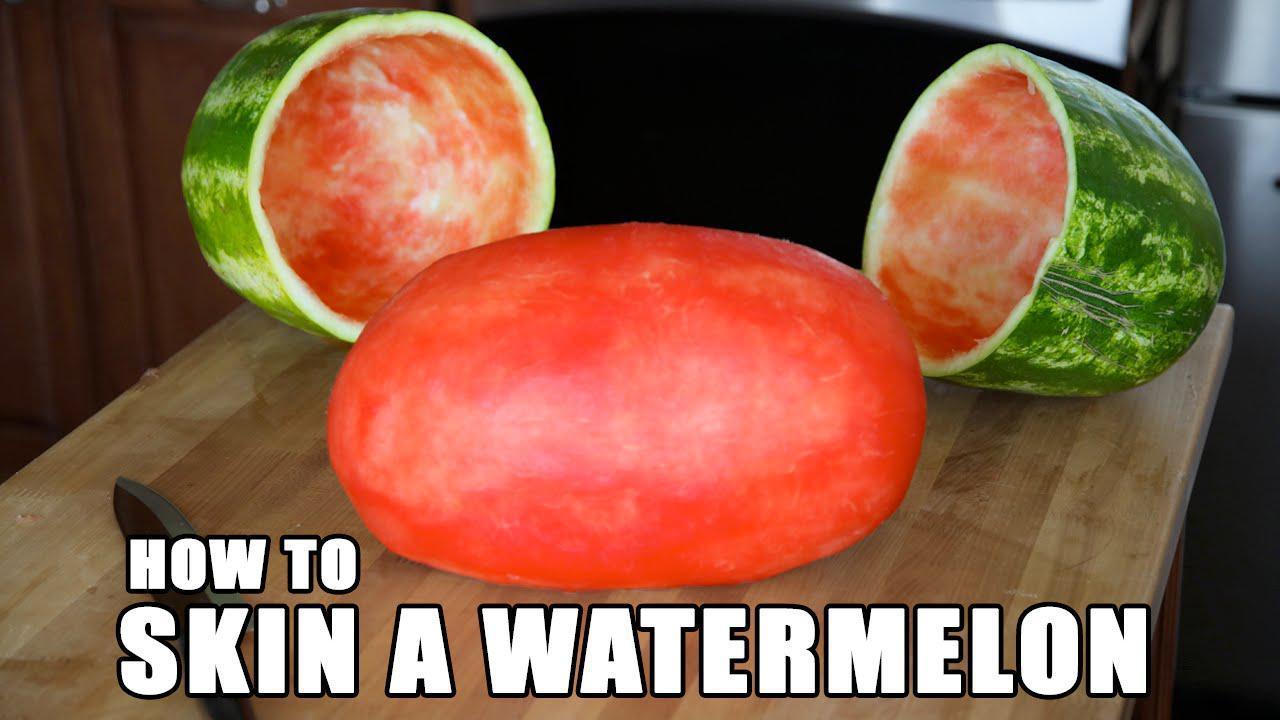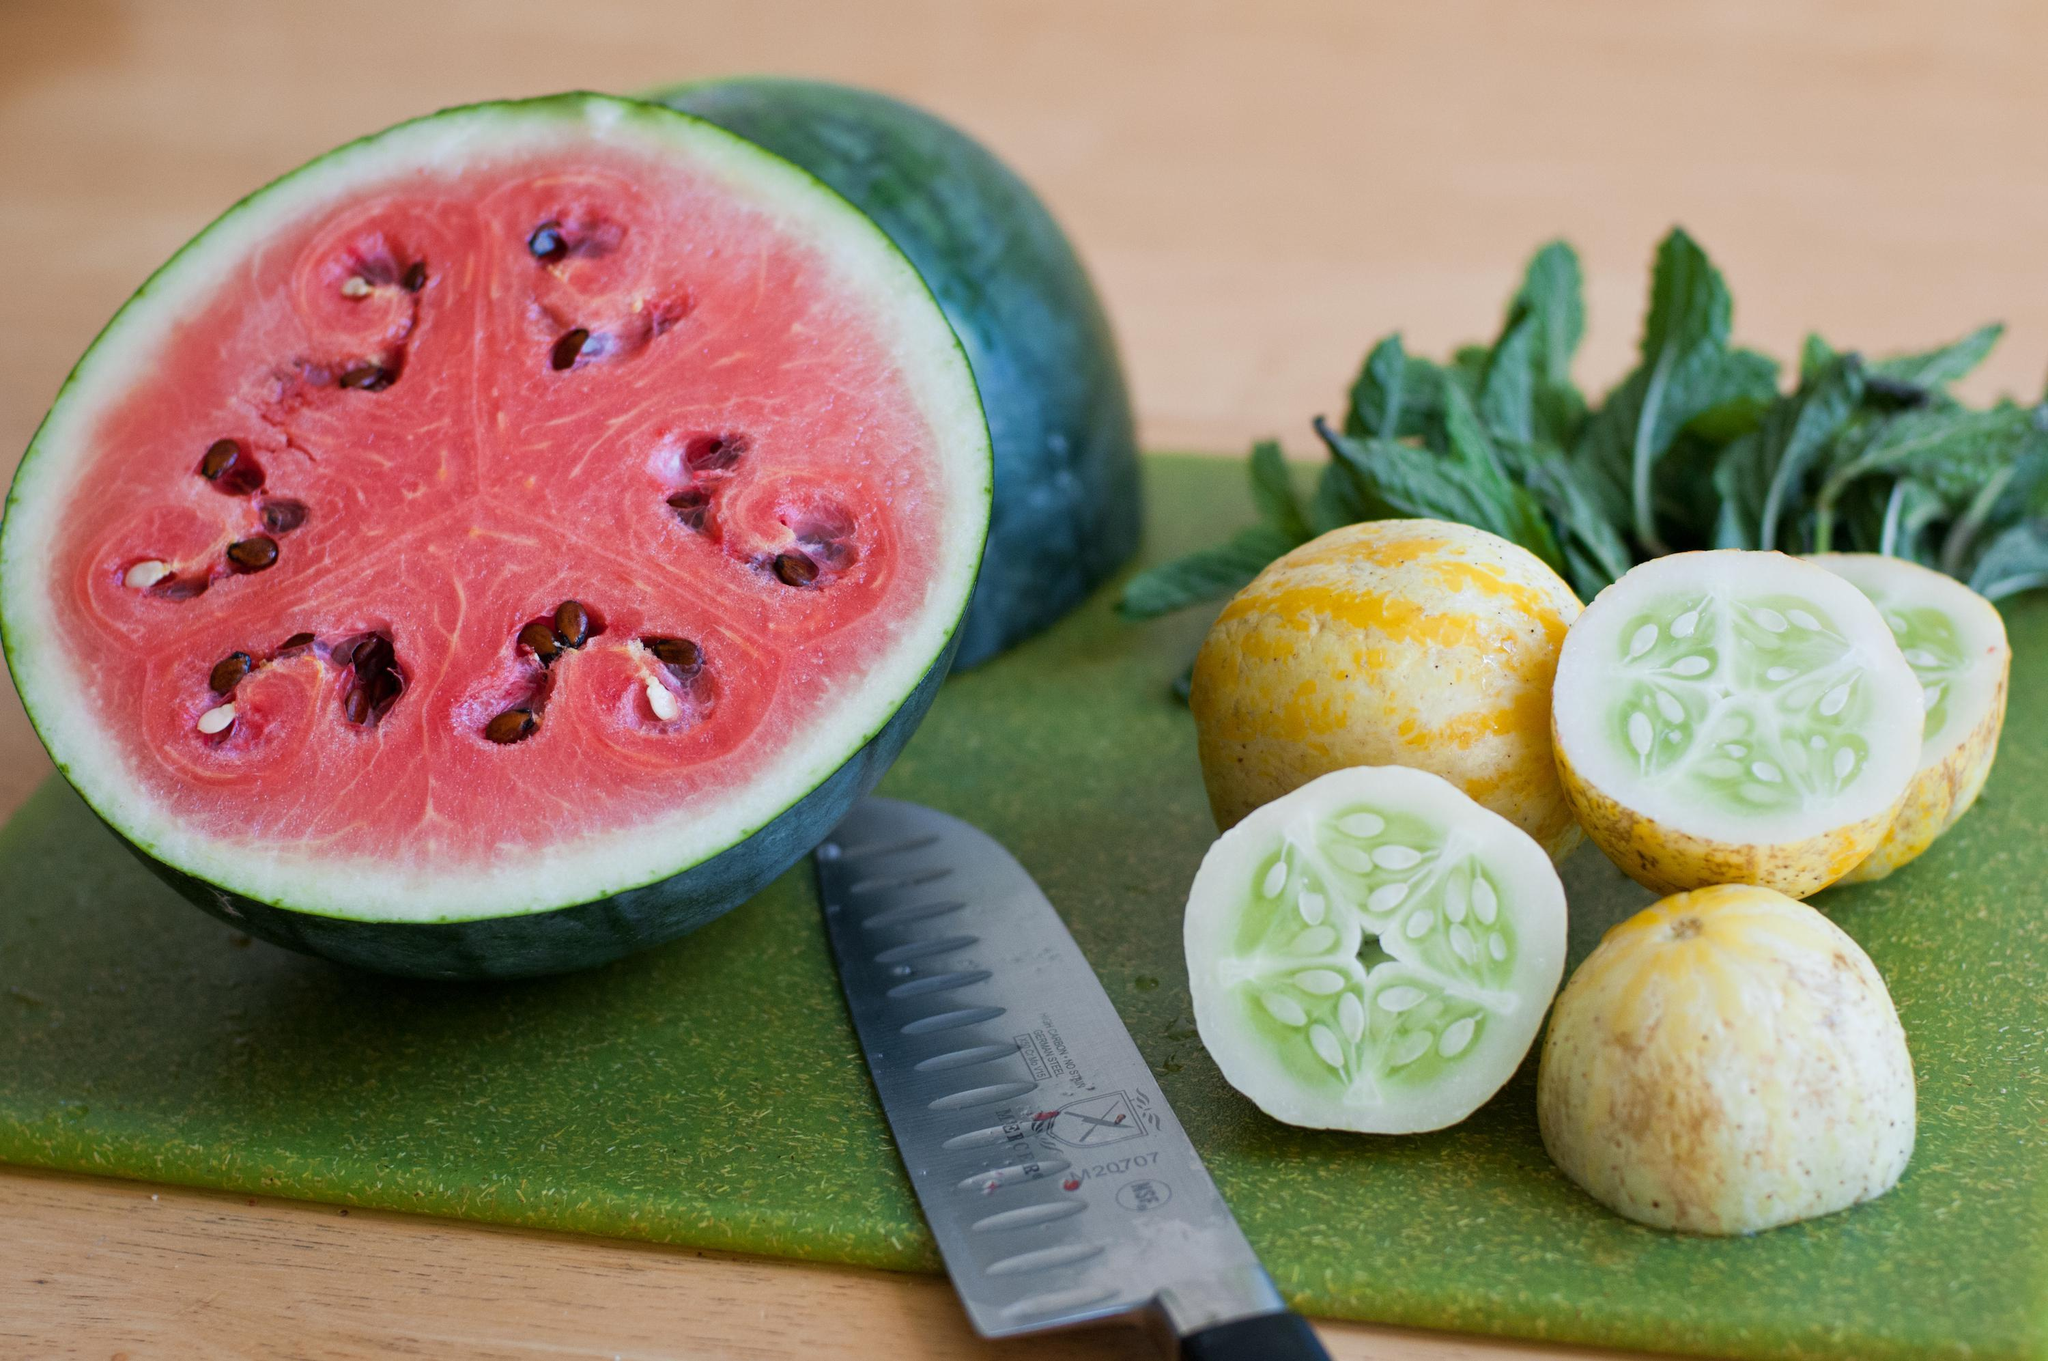The first image is the image on the left, the second image is the image on the right. Considering the images on both sides, is "There are three whole lemons in one of the images." valid? Answer yes or no. No. The first image is the image on the left, the second image is the image on the right. Assess this claim about the two images: "An image includes a serving pitcher and a garnished drink.". Correct or not? Answer yes or no. No. 